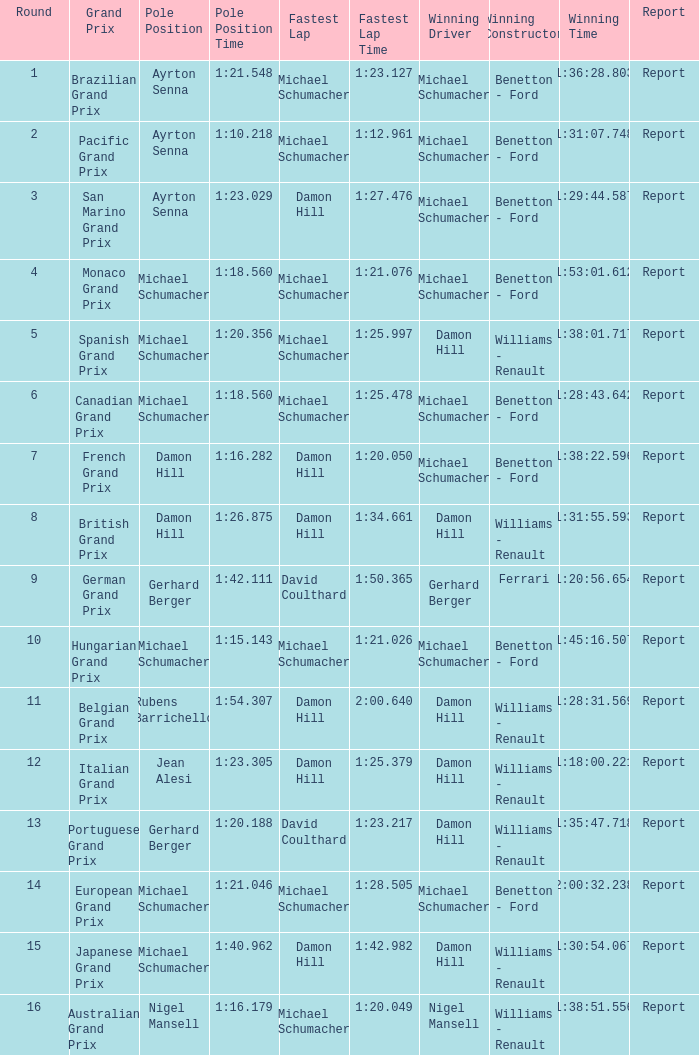Name the lowest round for when pole position and winning driver is michael schumacher 4.0. 